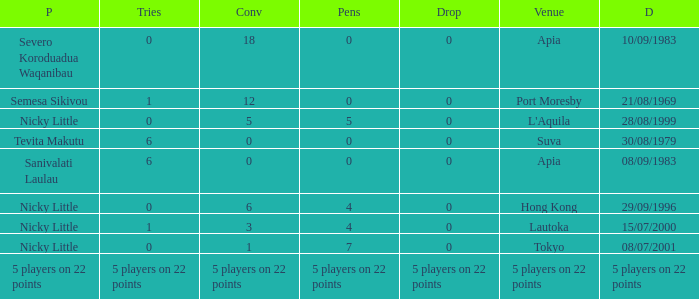How many drops did Nicky Little have in Hong Kong? 0.0. 